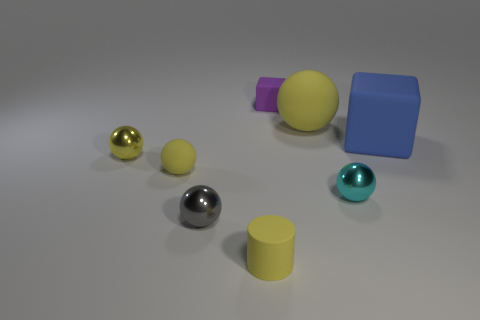What shape is the thing to the left of the rubber ball to the left of the small gray shiny sphere?
Keep it short and to the point. Sphere. Is there anything else of the same color as the small matte sphere?
Ensure brevity in your answer.  Yes. There is a metallic thing right of the small matte object right of the small cylinder; is there a cyan sphere in front of it?
Keep it short and to the point. No. Do the rubber sphere that is on the left side of the tiny yellow matte cylinder and the metal thing that is right of the small yellow cylinder have the same color?
Make the answer very short. No. There is a sphere that is the same size as the blue object; what material is it?
Give a very brief answer. Rubber. There is a yellow sphere that is right of the matte cube left of the tiny metallic sphere right of the small purple object; how big is it?
Your answer should be very brief. Large. How many other things are there of the same material as the purple object?
Make the answer very short. 4. What size is the object right of the small cyan shiny ball?
Provide a short and direct response. Large. What number of tiny shiny balls are behind the tiny gray sphere and to the left of the tiny cyan shiny ball?
Your answer should be very brief. 1. What is the material of the small object that is right of the rubber ball behind the tiny matte sphere?
Offer a terse response. Metal. 